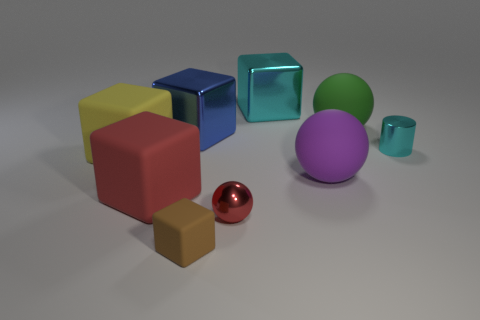What is the shape of the object that is the same color as the metal sphere?
Provide a succinct answer. Cube. There is a small shiny object that is left of the green object; what color is it?
Your response must be concise. Red. How many objects are either shiny things behind the green thing or matte spheres?
Offer a very short reply. 3. What color is the rubber thing that is the same size as the red metal sphere?
Offer a very short reply. Brown. Are there more matte objects that are on the left side of the big green matte thing than gray shiny cylinders?
Offer a terse response. Yes. The large object that is to the left of the purple sphere and behind the blue cube is made of what material?
Keep it short and to the point. Metal. There is a tiny thing on the right side of the small red thing; does it have the same color as the big metal thing to the right of the blue cube?
Keep it short and to the point. Yes. What number of other objects are the same size as the purple rubber thing?
Your response must be concise. 5. Is there a large blue shiny thing behind the matte cube behind the large matte ball in front of the cyan metallic cylinder?
Your answer should be compact. Yes. Is the material of the red cube that is behind the brown matte block the same as the small cube?
Your answer should be compact. Yes. 